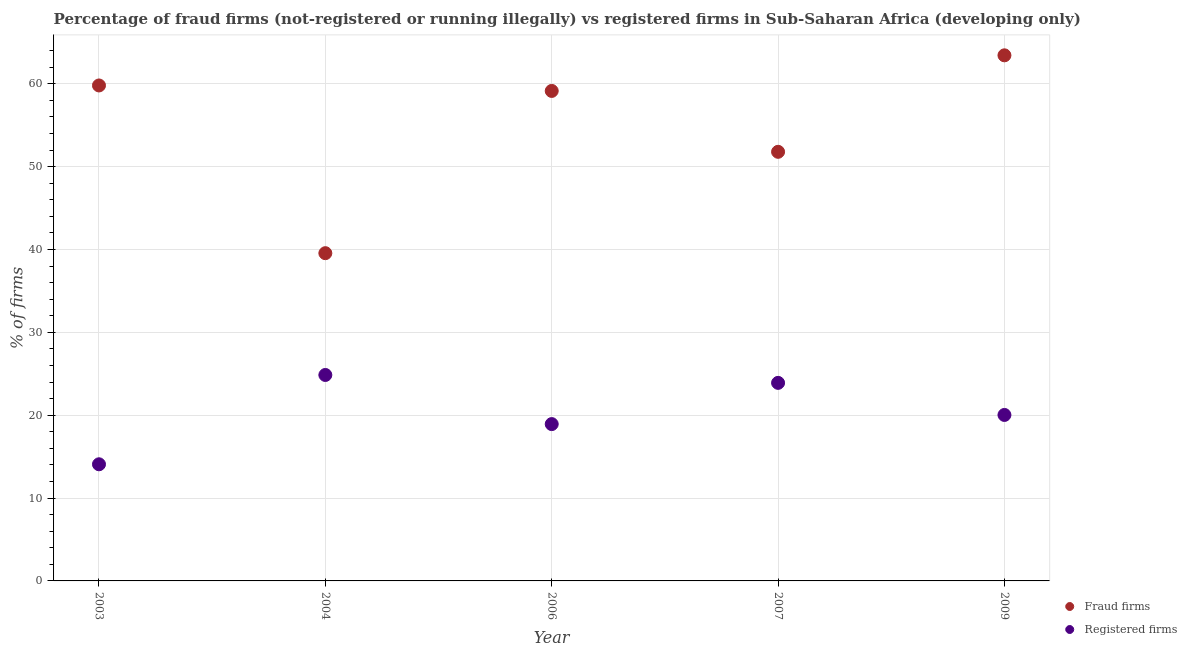What is the percentage of fraud firms in 2003?
Your answer should be very brief. 59.79. Across all years, what is the maximum percentage of fraud firms?
Your response must be concise. 63.43. Across all years, what is the minimum percentage of registered firms?
Your response must be concise. 14.07. What is the total percentage of fraud firms in the graph?
Your answer should be very brief. 273.68. What is the difference between the percentage of fraud firms in 2007 and that in 2009?
Ensure brevity in your answer.  -11.64. What is the difference between the percentage of fraud firms in 2003 and the percentage of registered firms in 2006?
Your answer should be very brief. 40.86. What is the average percentage of fraud firms per year?
Offer a very short reply. 54.74. In the year 2003, what is the difference between the percentage of fraud firms and percentage of registered firms?
Your response must be concise. 45.72. In how many years, is the percentage of fraud firms greater than 4 %?
Make the answer very short. 5. What is the ratio of the percentage of registered firms in 2004 to that in 2009?
Offer a terse response. 1.24. What is the difference between the highest and the second highest percentage of registered firms?
Ensure brevity in your answer.  0.95. What is the difference between the highest and the lowest percentage of registered firms?
Provide a succinct answer. 10.78. In how many years, is the percentage of fraud firms greater than the average percentage of fraud firms taken over all years?
Your answer should be compact. 3. Is the sum of the percentage of fraud firms in 2003 and 2006 greater than the maximum percentage of registered firms across all years?
Your response must be concise. Yes. Does the percentage of registered firms monotonically increase over the years?
Your response must be concise. No. Is the percentage of registered firms strictly less than the percentage of fraud firms over the years?
Provide a succinct answer. Yes. How many dotlines are there?
Your response must be concise. 2. Does the graph contain any zero values?
Your answer should be compact. No. Where does the legend appear in the graph?
Give a very brief answer. Bottom right. How many legend labels are there?
Offer a terse response. 2. How are the legend labels stacked?
Offer a very short reply. Vertical. What is the title of the graph?
Provide a succinct answer. Percentage of fraud firms (not-registered or running illegally) vs registered firms in Sub-Saharan Africa (developing only). Does "Urban Population" appear as one of the legend labels in the graph?
Provide a short and direct response. No. What is the label or title of the Y-axis?
Offer a very short reply. % of firms. What is the % of firms of Fraud firms in 2003?
Your response must be concise. 59.79. What is the % of firms in Registered firms in 2003?
Your answer should be compact. 14.07. What is the % of firms of Fraud firms in 2004?
Offer a very short reply. 39.55. What is the % of firms in Registered firms in 2004?
Your answer should be compact. 24.85. What is the % of firms in Fraud firms in 2006?
Ensure brevity in your answer.  59.13. What is the % of firms of Registered firms in 2006?
Offer a terse response. 18.93. What is the % of firms of Fraud firms in 2007?
Offer a terse response. 51.78. What is the % of firms of Registered firms in 2007?
Keep it short and to the point. 23.9. What is the % of firms of Fraud firms in 2009?
Provide a succinct answer. 63.43. What is the % of firms of Registered firms in 2009?
Offer a very short reply. 20.03. Across all years, what is the maximum % of firms in Fraud firms?
Offer a very short reply. 63.43. Across all years, what is the maximum % of firms in Registered firms?
Your response must be concise. 24.85. Across all years, what is the minimum % of firms of Fraud firms?
Your response must be concise. 39.55. Across all years, what is the minimum % of firms in Registered firms?
Make the answer very short. 14.07. What is the total % of firms in Fraud firms in the graph?
Provide a succinct answer. 273.68. What is the total % of firms of Registered firms in the graph?
Offer a very short reply. 101.78. What is the difference between the % of firms in Fraud firms in 2003 and that in 2004?
Make the answer very short. 20.24. What is the difference between the % of firms in Registered firms in 2003 and that in 2004?
Provide a succinct answer. -10.78. What is the difference between the % of firms in Fraud firms in 2003 and that in 2006?
Keep it short and to the point. 0.66. What is the difference between the % of firms in Registered firms in 2003 and that in 2006?
Your answer should be compact. -4.85. What is the difference between the % of firms of Fraud firms in 2003 and that in 2007?
Make the answer very short. 8.01. What is the difference between the % of firms of Registered firms in 2003 and that in 2007?
Ensure brevity in your answer.  -9.82. What is the difference between the % of firms of Fraud firms in 2003 and that in 2009?
Give a very brief answer. -3.64. What is the difference between the % of firms in Registered firms in 2003 and that in 2009?
Your response must be concise. -5.95. What is the difference between the % of firms in Fraud firms in 2004 and that in 2006?
Offer a very short reply. -19.58. What is the difference between the % of firms in Registered firms in 2004 and that in 2006?
Ensure brevity in your answer.  5.93. What is the difference between the % of firms of Fraud firms in 2004 and that in 2007?
Your answer should be compact. -12.23. What is the difference between the % of firms in Registered firms in 2004 and that in 2007?
Your answer should be very brief. 0.95. What is the difference between the % of firms of Fraud firms in 2004 and that in 2009?
Offer a very short reply. -23.88. What is the difference between the % of firms of Registered firms in 2004 and that in 2009?
Offer a terse response. 4.82. What is the difference between the % of firms of Fraud firms in 2006 and that in 2007?
Your answer should be compact. 7.35. What is the difference between the % of firms in Registered firms in 2006 and that in 2007?
Keep it short and to the point. -4.97. What is the difference between the % of firms of Fraud firms in 2006 and that in 2009?
Offer a very short reply. -4.3. What is the difference between the % of firms of Registered firms in 2006 and that in 2009?
Keep it short and to the point. -1.1. What is the difference between the % of firms of Fraud firms in 2007 and that in 2009?
Your answer should be compact. -11.64. What is the difference between the % of firms of Registered firms in 2007 and that in 2009?
Your response must be concise. 3.87. What is the difference between the % of firms in Fraud firms in 2003 and the % of firms in Registered firms in 2004?
Give a very brief answer. 34.94. What is the difference between the % of firms of Fraud firms in 2003 and the % of firms of Registered firms in 2006?
Ensure brevity in your answer.  40.87. What is the difference between the % of firms in Fraud firms in 2003 and the % of firms in Registered firms in 2007?
Make the answer very short. 35.89. What is the difference between the % of firms in Fraud firms in 2003 and the % of firms in Registered firms in 2009?
Offer a terse response. 39.76. What is the difference between the % of firms of Fraud firms in 2004 and the % of firms of Registered firms in 2006?
Provide a short and direct response. 20.62. What is the difference between the % of firms in Fraud firms in 2004 and the % of firms in Registered firms in 2007?
Provide a succinct answer. 15.65. What is the difference between the % of firms of Fraud firms in 2004 and the % of firms of Registered firms in 2009?
Provide a succinct answer. 19.52. What is the difference between the % of firms of Fraud firms in 2006 and the % of firms of Registered firms in 2007?
Provide a short and direct response. 35.23. What is the difference between the % of firms of Fraud firms in 2006 and the % of firms of Registered firms in 2009?
Your answer should be compact. 39.1. What is the difference between the % of firms of Fraud firms in 2007 and the % of firms of Registered firms in 2009?
Provide a succinct answer. 31.75. What is the average % of firms of Fraud firms per year?
Keep it short and to the point. 54.74. What is the average % of firms of Registered firms per year?
Your answer should be very brief. 20.36. In the year 2003, what is the difference between the % of firms in Fraud firms and % of firms in Registered firms?
Your answer should be compact. 45.72. In the year 2004, what is the difference between the % of firms of Fraud firms and % of firms of Registered firms?
Your response must be concise. 14.7. In the year 2006, what is the difference between the % of firms of Fraud firms and % of firms of Registered firms?
Make the answer very short. 40.2. In the year 2007, what is the difference between the % of firms in Fraud firms and % of firms in Registered firms?
Give a very brief answer. 27.88. In the year 2009, what is the difference between the % of firms of Fraud firms and % of firms of Registered firms?
Make the answer very short. 43.4. What is the ratio of the % of firms in Fraud firms in 2003 to that in 2004?
Your answer should be very brief. 1.51. What is the ratio of the % of firms of Registered firms in 2003 to that in 2004?
Provide a succinct answer. 0.57. What is the ratio of the % of firms of Fraud firms in 2003 to that in 2006?
Keep it short and to the point. 1.01. What is the ratio of the % of firms in Registered firms in 2003 to that in 2006?
Your answer should be very brief. 0.74. What is the ratio of the % of firms in Fraud firms in 2003 to that in 2007?
Offer a very short reply. 1.15. What is the ratio of the % of firms of Registered firms in 2003 to that in 2007?
Your answer should be compact. 0.59. What is the ratio of the % of firms in Fraud firms in 2003 to that in 2009?
Offer a very short reply. 0.94. What is the ratio of the % of firms in Registered firms in 2003 to that in 2009?
Offer a terse response. 0.7. What is the ratio of the % of firms in Fraud firms in 2004 to that in 2006?
Give a very brief answer. 0.67. What is the ratio of the % of firms in Registered firms in 2004 to that in 2006?
Offer a very short reply. 1.31. What is the ratio of the % of firms of Fraud firms in 2004 to that in 2007?
Your response must be concise. 0.76. What is the ratio of the % of firms in Registered firms in 2004 to that in 2007?
Your response must be concise. 1.04. What is the ratio of the % of firms in Fraud firms in 2004 to that in 2009?
Your answer should be very brief. 0.62. What is the ratio of the % of firms of Registered firms in 2004 to that in 2009?
Give a very brief answer. 1.24. What is the ratio of the % of firms of Fraud firms in 2006 to that in 2007?
Provide a short and direct response. 1.14. What is the ratio of the % of firms of Registered firms in 2006 to that in 2007?
Make the answer very short. 0.79. What is the ratio of the % of firms of Fraud firms in 2006 to that in 2009?
Offer a terse response. 0.93. What is the ratio of the % of firms in Registered firms in 2006 to that in 2009?
Offer a terse response. 0.94. What is the ratio of the % of firms of Fraud firms in 2007 to that in 2009?
Provide a succinct answer. 0.82. What is the ratio of the % of firms in Registered firms in 2007 to that in 2009?
Make the answer very short. 1.19. What is the difference between the highest and the second highest % of firms of Fraud firms?
Offer a very short reply. 3.64. What is the difference between the highest and the second highest % of firms in Registered firms?
Keep it short and to the point. 0.95. What is the difference between the highest and the lowest % of firms of Fraud firms?
Ensure brevity in your answer.  23.88. What is the difference between the highest and the lowest % of firms in Registered firms?
Make the answer very short. 10.78. 